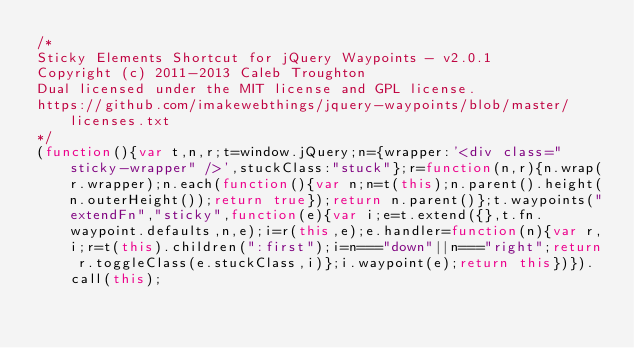<code> <loc_0><loc_0><loc_500><loc_500><_JavaScript_>/*
Sticky Elements Shortcut for jQuery Waypoints - v2.0.1
Copyright (c) 2011-2013 Caleb Troughton
Dual licensed under the MIT license and GPL license.
https://github.com/imakewebthings/jquery-waypoints/blob/master/licenses.txt
*/
(function(){var t,n,r;t=window.jQuery;n={wrapper:'<div class="sticky-wrapper" />',stuckClass:"stuck"};r=function(n,r){n.wrap(r.wrapper);n.each(function(){var n;n=t(this);n.parent().height(n.outerHeight());return true});return n.parent()};t.waypoints("extendFn","sticky",function(e){var i;e=t.extend({},t.fn.waypoint.defaults,n,e);i=r(this,e);e.handler=function(n){var r,i;r=t(this).children(":first");i=n==="down"||n==="right";return r.toggleClass(e.stuckClass,i)};i.waypoint(e);return this})}).call(this);</code> 